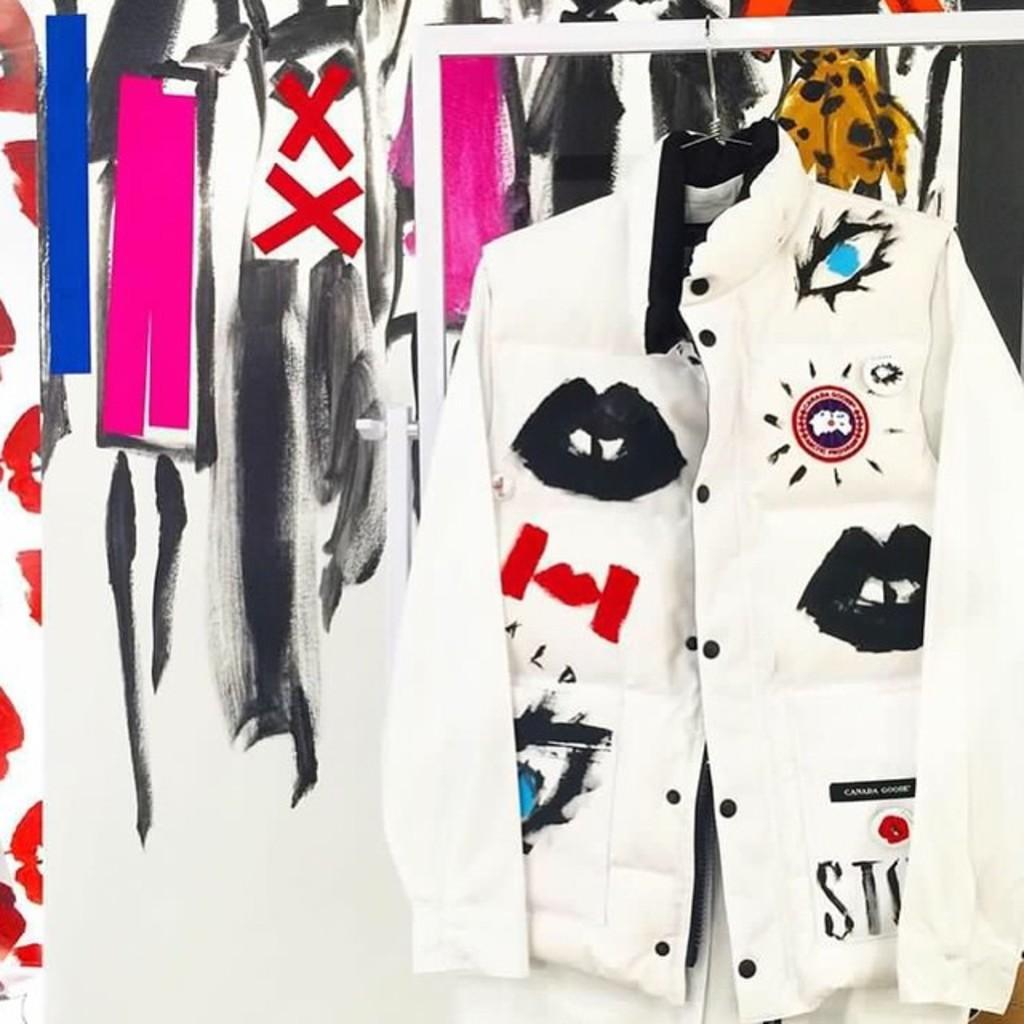Can you describe this image briefly? In this picture we can see a jacket hanged to a stand and in the background we can see painting. 